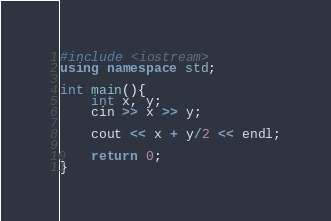Convert code to text. <code><loc_0><loc_0><loc_500><loc_500><_C++_>#include <iostream>
using namespace std;

int main(){
	int x, y;
	cin >> x >> y;

	cout << x + y/2 << endl;

	return 0;
}</code> 